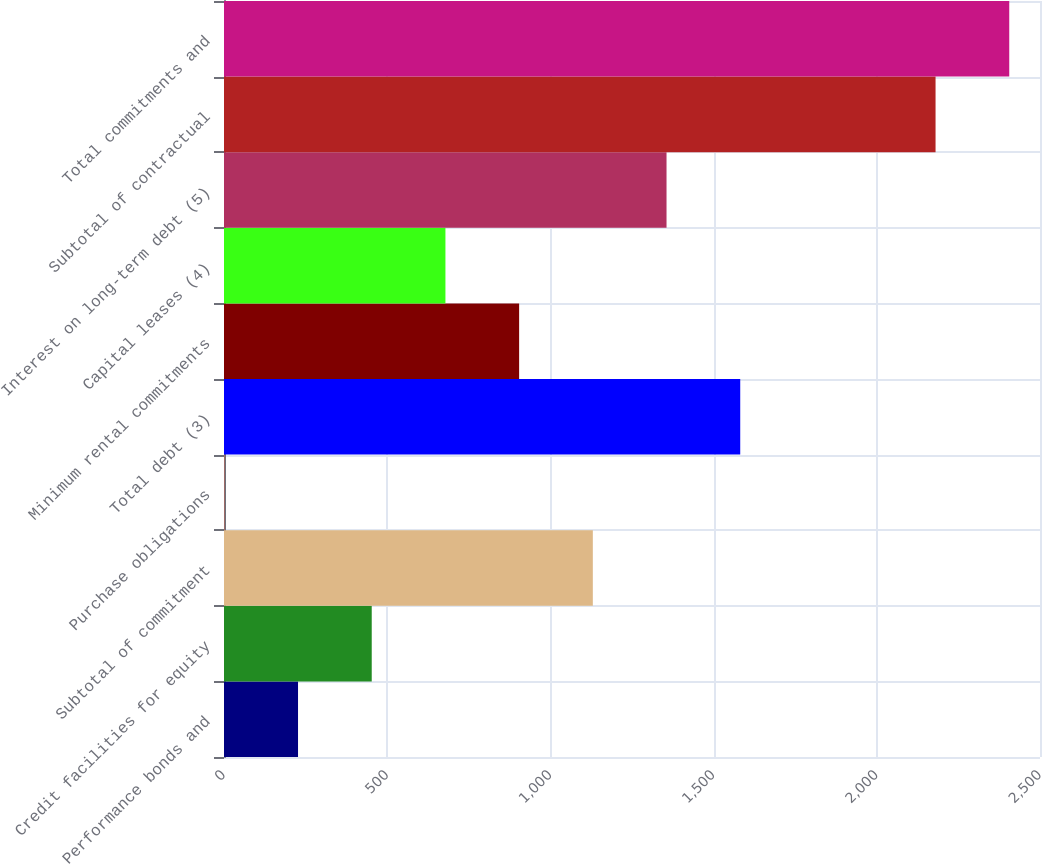<chart> <loc_0><loc_0><loc_500><loc_500><bar_chart><fcel>Performance bonds and<fcel>Credit facilities for equity<fcel>Subtotal of commitment<fcel>Purchase obligations<fcel>Total debt (3)<fcel>Minimum rental commitments<fcel>Capital leases (4)<fcel>Interest on long-term debt (5)<fcel>Subtotal of contractual<fcel>Total commitments and<nl><fcel>226.8<fcel>452.6<fcel>1130<fcel>1<fcel>1581.6<fcel>904.2<fcel>678.4<fcel>1355.8<fcel>2180<fcel>2405.8<nl></chart> 